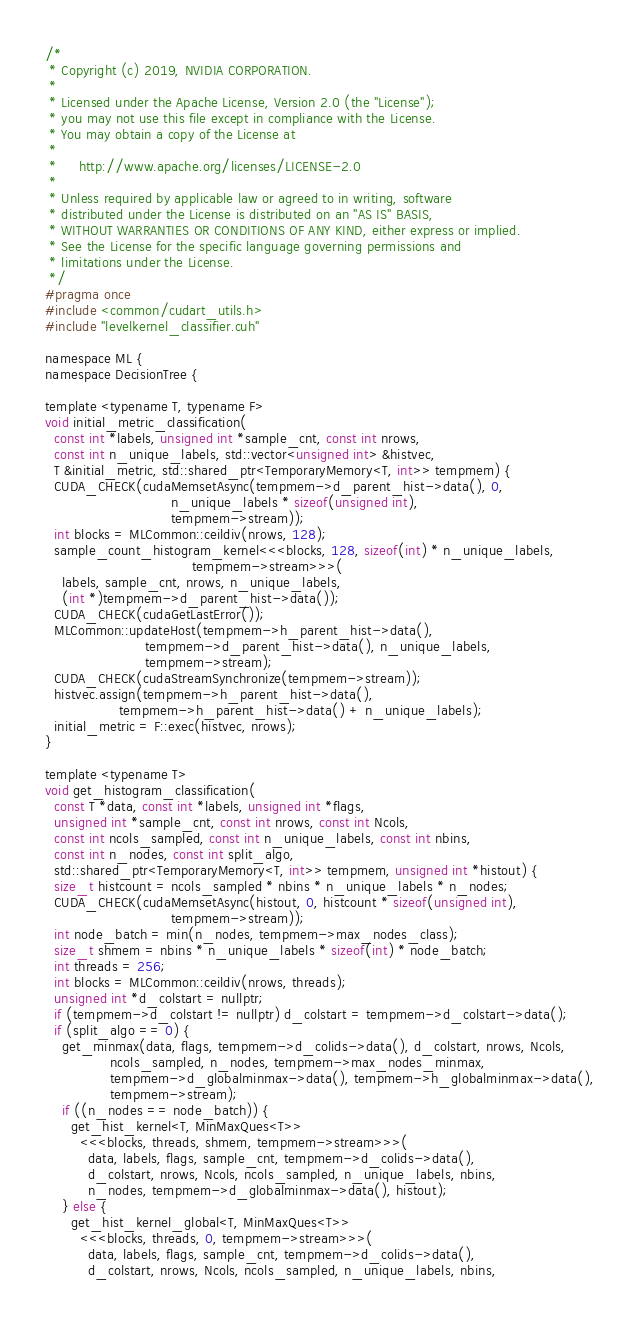<code> <loc_0><loc_0><loc_500><loc_500><_Cuda_>/*
 * Copyright (c) 2019, NVIDIA CORPORATION.
 *
 * Licensed under the Apache License, Version 2.0 (the "License");
 * you may not use this file except in compliance with the License.
 * You may obtain a copy of the License at
 *
 *     http://www.apache.org/licenses/LICENSE-2.0
 *
 * Unless required by applicable law or agreed to in writing, software
 * distributed under the License is distributed on an "AS IS" BASIS,
 * WITHOUT WARRANTIES OR CONDITIONS OF ANY KIND, either express or implied.
 * See the License for the specific language governing permissions and
 * limitations under the License.
 */
#pragma once
#include <common/cudart_utils.h>
#include "levelkernel_classifier.cuh"

namespace ML {
namespace DecisionTree {

template <typename T, typename F>
void initial_metric_classification(
  const int *labels, unsigned int *sample_cnt, const int nrows,
  const int n_unique_labels, std::vector<unsigned int> &histvec,
  T &initial_metric, std::shared_ptr<TemporaryMemory<T, int>> tempmem) {
  CUDA_CHECK(cudaMemsetAsync(tempmem->d_parent_hist->data(), 0,
                             n_unique_labels * sizeof(unsigned int),
                             tempmem->stream));
  int blocks = MLCommon::ceildiv(nrows, 128);
  sample_count_histogram_kernel<<<blocks, 128, sizeof(int) * n_unique_labels,
                                  tempmem->stream>>>(
    labels, sample_cnt, nrows, n_unique_labels,
    (int *)tempmem->d_parent_hist->data());
  CUDA_CHECK(cudaGetLastError());
  MLCommon::updateHost(tempmem->h_parent_hist->data(),
                       tempmem->d_parent_hist->data(), n_unique_labels,
                       tempmem->stream);
  CUDA_CHECK(cudaStreamSynchronize(tempmem->stream));
  histvec.assign(tempmem->h_parent_hist->data(),
                 tempmem->h_parent_hist->data() + n_unique_labels);
  initial_metric = F::exec(histvec, nrows);
}

template <typename T>
void get_histogram_classification(
  const T *data, const int *labels, unsigned int *flags,
  unsigned int *sample_cnt, const int nrows, const int Ncols,
  const int ncols_sampled, const int n_unique_labels, const int nbins,
  const int n_nodes, const int split_algo,
  std::shared_ptr<TemporaryMemory<T, int>> tempmem, unsigned int *histout) {
  size_t histcount = ncols_sampled * nbins * n_unique_labels * n_nodes;
  CUDA_CHECK(cudaMemsetAsync(histout, 0, histcount * sizeof(unsigned int),
                             tempmem->stream));
  int node_batch = min(n_nodes, tempmem->max_nodes_class);
  size_t shmem = nbins * n_unique_labels * sizeof(int) * node_batch;
  int threads = 256;
  int blocks = MLCommon::ceildiv(nrows, threads);
  unsigned int *d_colstart = nullptr;
  if (tempmem->d_colstart != nullptr) d_colstart = tempmem->d_colstart->data();
  if (split_algo == 0) {
    get_minmax(data, flags, tempmem->d_colids->data(), d_colstart, nrows, Ncols,
               ncols_sampled, n_nodes, tempmem->max_nodes_minmax,
               tempmem->d_globalminmax->data(), tempmem->h_globalminmax->data(),
               tempmem->stream);
    if ((n_nodes == node_batch)) {
      get_hist_kernel<T, MinMaxQues<T>>
        <<<blocks, threads, shmem, tempmem->stream>>>(
          data, labels, flags, sample_cnt, tempmem->d_colids->data(),
          d_colstart, nrows, Ncols, ncols_sampled, n_unique_labels, nbins,
          n_nodes, tempmem->d_globalminmax->data(), histout);
    } else {
      get_hist_kernel_global<T, MinMaxQues<T>>
        <<<blocks, threads, 0, tempmem->stream>>>(
          data, labels, flags, sample_cnt, tempmem->d_colids->data(),
          d_colstart, nrows, Ncols, ncols_sampled, n_unique_labels, nbins,</code> 